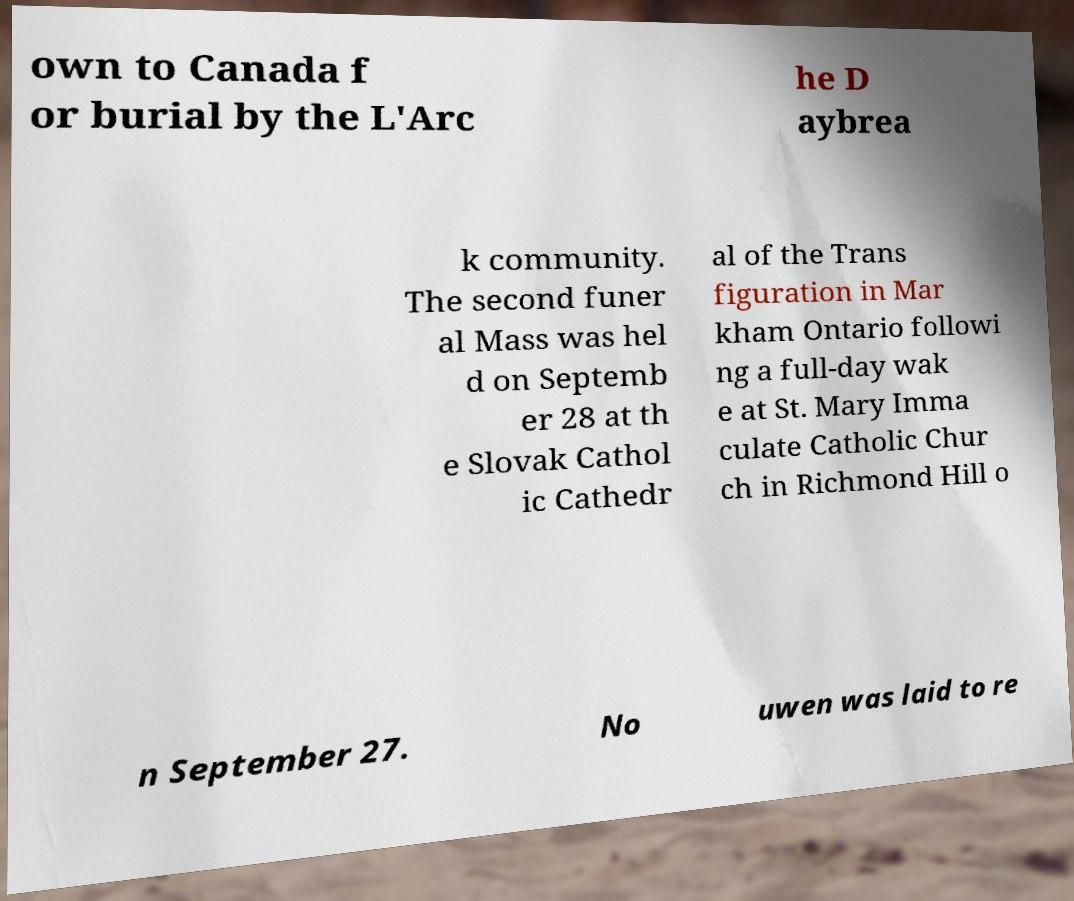Can you read and provide the text displayed in the image?This photo seems to have some interesting text. Can you extract and type it out for me? own to Canada f or burial by the L'Arc he D aybrea k community. The second funer al Mass was hel d on Septemb er 28 at th e Slovak Cathol ic Cathedr al of the Trans figuration in Mar kham Ontario followi ng a full-day wak e at St. Mary Imma culate Catholic Chur ch in Richmond Hill o n September 27. No uwen was laid to re 